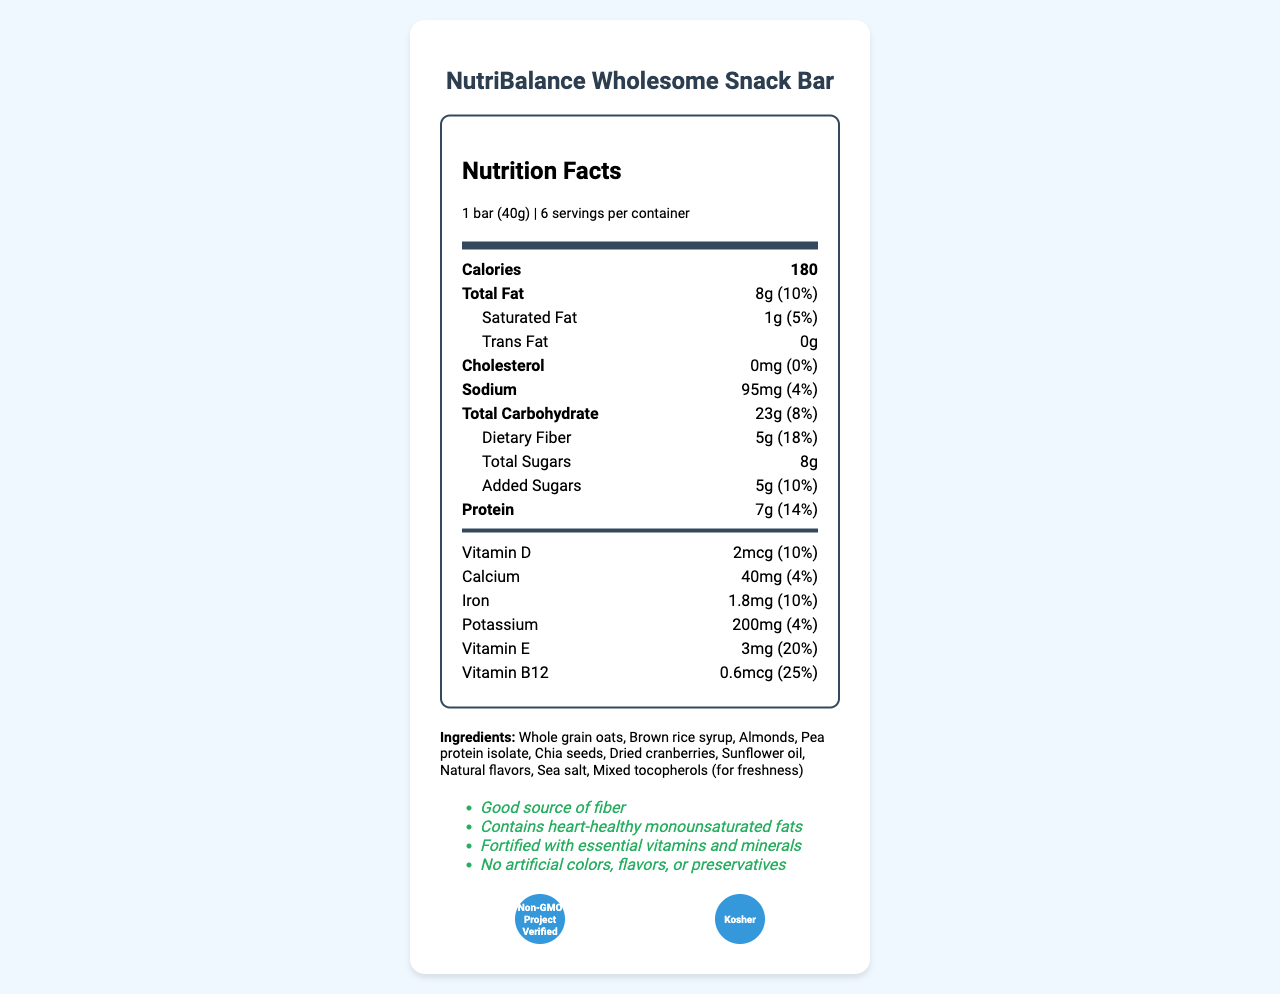how many servings are there per container? The document lists that there are 6 servings per container.
Answer: 6 what is the serving size of the NutriBalance Wholesome Snack Bar? The serving size is specified as 1 bar (40g) in the nutritional facts.
Answer: 1 bar (40g) how many calories are in one serving? The document lists the caloric content per serving as 180 calories.
Answer: 180 how much dietary fiber is in each serving? Each serving contains 5g of dietary fiber as listed in the nutritional breakdown of carbohydrates.
Answer: 5g what percent of the daily value of protein does each serving provide? The document states that each serving provides 14% of the daily value of protein.
Answer: 14% how much saturated fat does each serving contain? A. 1g B. 2g C. 5g D. 0g The document specifies that each serving contains 1g of saturated fat.
Answer: A. 1g how many grams of total sugars are in each serving? A. 5g B. 7g C. 8g D. 10g The document indicates that each serving contains 8g of total sugars.
Answer: C. 8g does the nutrition facts label state that the product contains any cholesterol? The label shows 0mg of cholesterol, meaning it does not contain any cholesterol.
Answer: No is the NutriBalance Wholesome Snack Bar fortified with any essential vitamins and minerals? The document mentions that the product is fortified with vitamins and minerals like Vitamin D, Vitamin E, and Vitamin B12.
Answer: Yes summarize the main health benefits mentioned for the NutriBalance Wholesome Snack Bar. The document highlights the product's health benefits by emphasizing its high fiber content, heart-healthy fats, vitamin fortification, absence of artificial additives, and certifications.
Answer: The NutriBalance Wholesome Snack Bar is a snack that is a good source of fiber, contains heart-healthy monounsaturated fats, and is fortified with essential vitamins and minerals. It also avoids artificial colors, flavors, or preservatives, and has certifications such as 'Non-GMO Project Verified' and 'Kosher'. what is the phone number provided for consumer inquiries? The document lists the consumer hotline as 1-800-123-4567 in the additional information section.
Answer: 1-800-123-4567 how much vitamin B12 does each serving contain? The document specifies that each serving contains 0.6mcg of vitamin B12.
Answer: 0.6mcg what allergens are mentioned in the document? The allergen information states that the product contains almonds and may also have traces of peanuts and other tree nuts.
Answer: Contains almonds. May contain traces of peanuts and other tree nuts. does the product contain any artificial colors, flavors, or preservatives? The health claims mention that the product contains no artificial colors, flavors, or preservatives.
Answer: No what is the main ingredient listed for the NutriBalance Wholesome Snack Bar? The first ingredient listed, which often indicates the primary ingredient, is whole grain oats.
Answer: Whole grain oats what percentage of the daily value of sodium does each serving provides? The document indicates that each serving provides 4% of the daily value of sodium.
Answer: 4% where should the NutriBalance Wholesome Snack Bar be stored? The additional information section advises storing the product in a cool, dry place.
Answer: Store in a cool, dry place which company manufactures the NutriBalance Wholesome Snack Bar? The additional information specifies that the manufacturer is Wholesome Snacks Inc., located in Boulder, CO.
Answer: Wholesome Snacks Inc. what is the total amount of fats in each serving? The document lists that there are a total of 8g of fats in each serving.
Answer: 8g does the NutriBalance Wholesome Snack Bar contain any Vitamin C? The document does not provide any information about Vitamin C content, so it cannot be determined.
Answer: Cannot be determined 